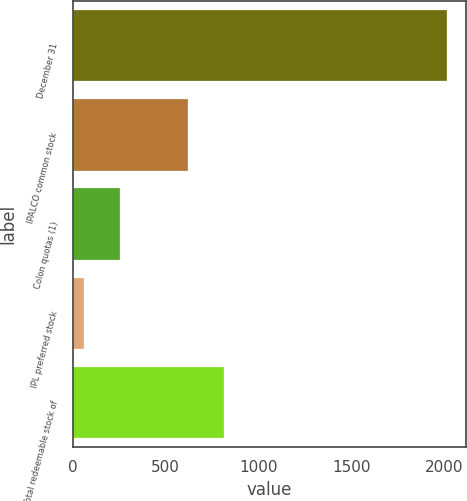<chart> <loc_0><loc_0><loc_500><loc_500><bar_chart><fcel>December 31<fcel>IPALCO common stock<fcel>Colon quotas (1)<fcel>IPL preferred stock<fcel>Total redeemable stock of<nl><fcel>2016<fcel>618<fcel>255.6<fcel>60<fcel>813.6<nl></chart> 